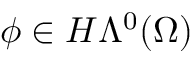<formula> <loc_0><loc_0><loc_500><loc_500>\phi \in H \Lambda ^ { 0 } ( \Omega )</formula> 